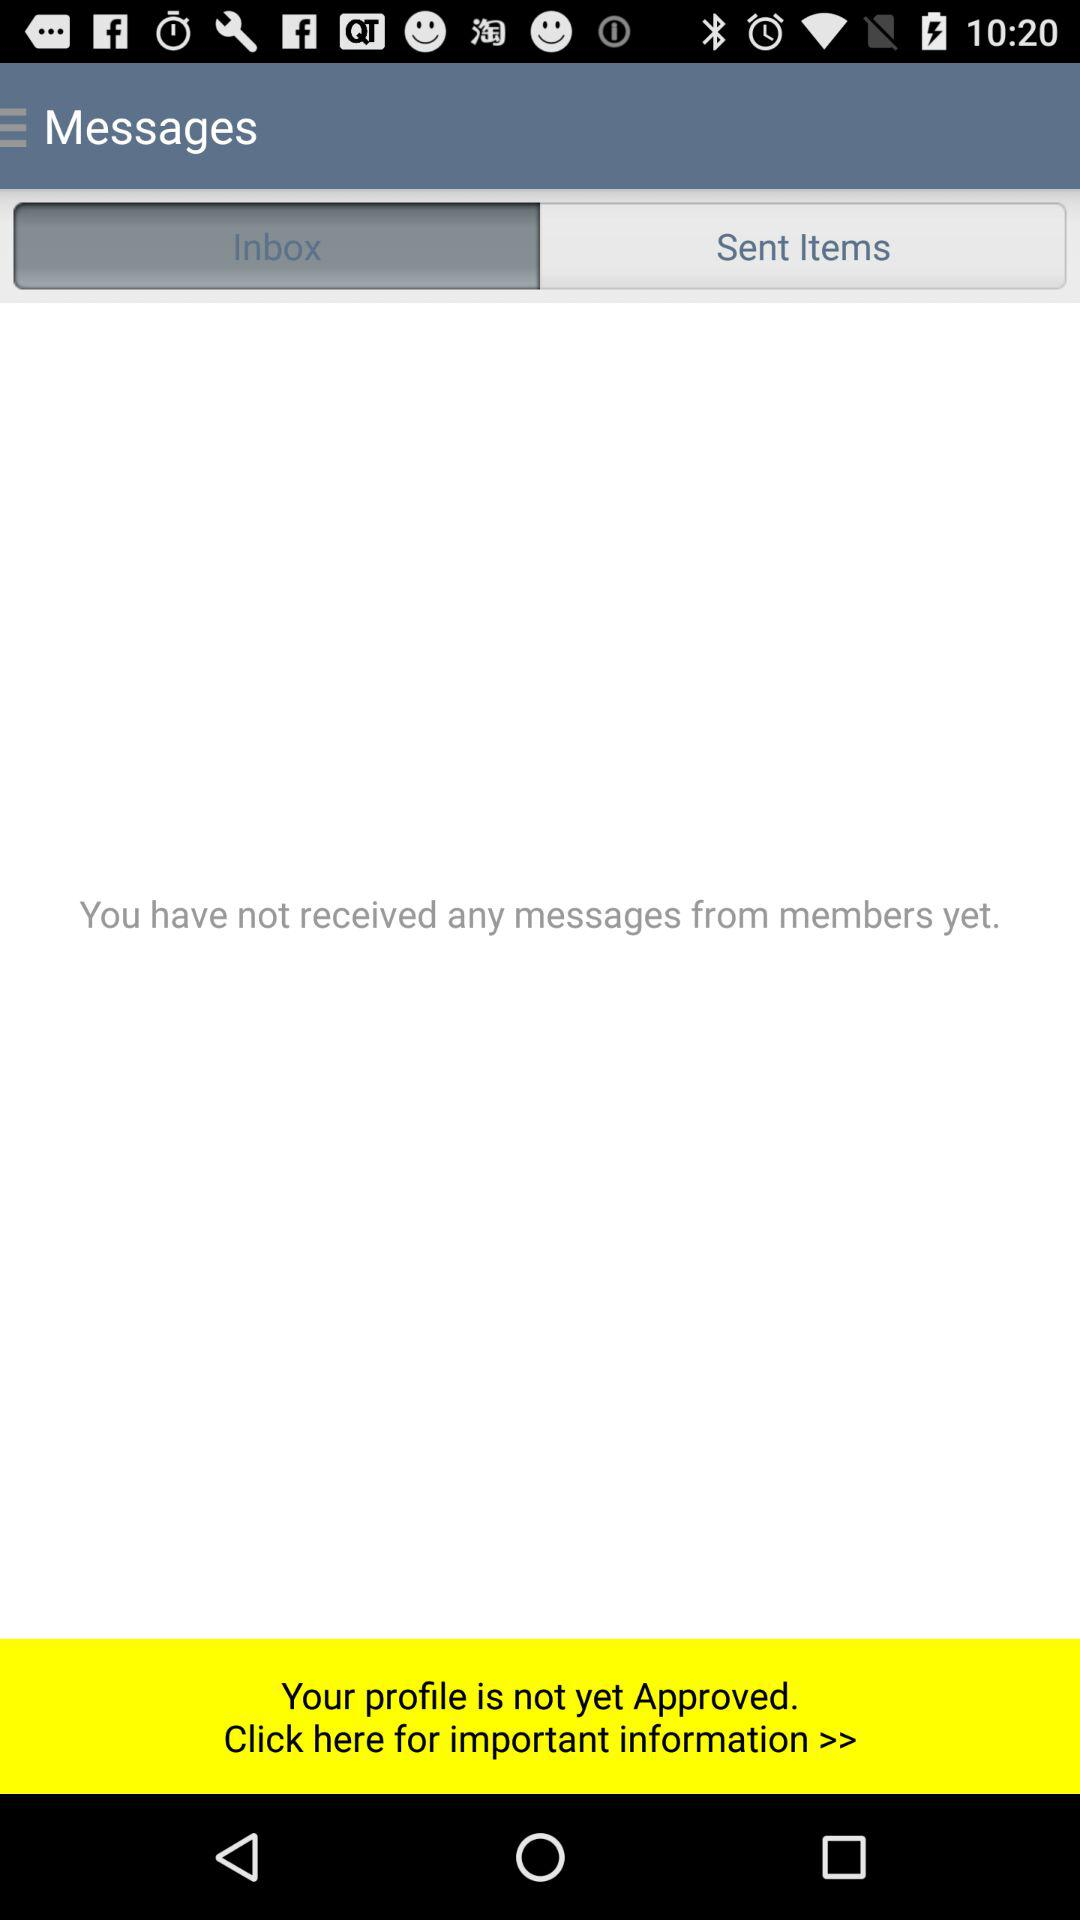How many messages have I received from members?
Answer the question using a single word or phrase. 0 